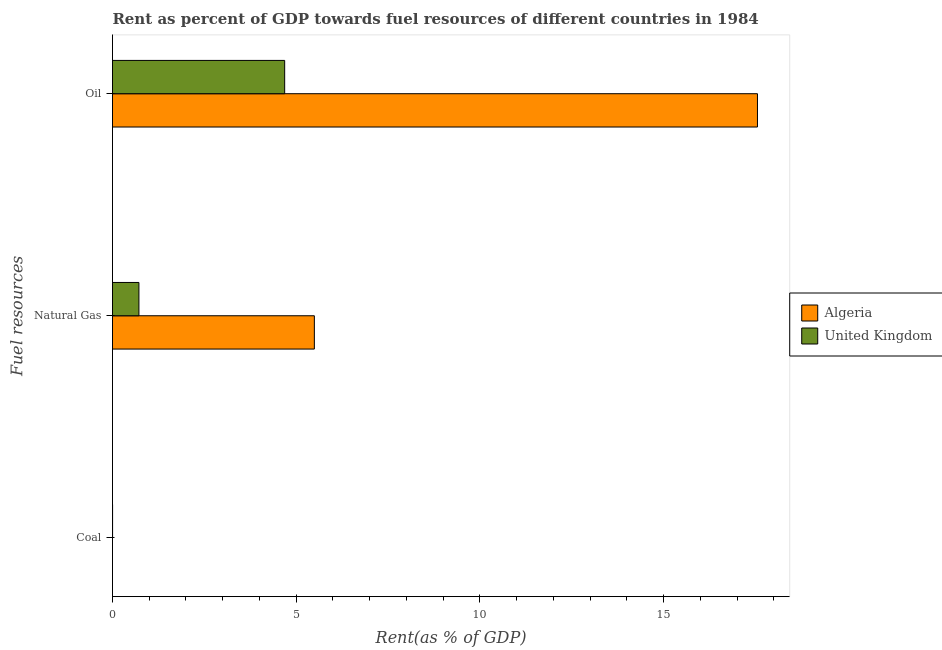How many different coloured bars are there?
Offer a very short reply. 2. How many groups of bars are there?
Make the answer very short. 3. Are the number of bars per tick equal to the number of legend labels?
Offer a terse response. Yes. Are the number of bars on each tick of the Y-axis equal?
Offer a terse response. Yes. What is the label of the 1st group of bars from the top?
Ensure brevity in your answer.  Oil. What is the rent towards oil in Algeria?
Your answer should be compact. 17.56. Across all countries, what is the maximum rent towards oil?
Ensure brevity in your answer.  17.56. Across all countries, what is the minimum rent towards oil?
Ensure brevity in your answer.  4.69. In which country was the rent towards oil minimum?
Your answer should be very brief. United Kingdom. What is the total rent towards natural gas in the graph?
Keep it short and to the point. 6.21. What is the difference between the rent towards natural gas in Algeria and that in United Kingdom?
Provide a short and direct response. 4.78. What is the difference between the rent towards oil in United Kingdom and the rent towards natural gas in Algeria?
Provide a short and direct response. -0.81. What is the average rent towards oil per country?
Provide a succinct answer. 11.12. What is the difference between the rent towards natural gas and rent towards oil in United Kingdom?
Your response must be concise. -3.97. In how many countries, is the rent towards natural gas greater than 7 %?
Ensure brevity in your answer.  0. What is the ratio of the rent towards natural gas in United Kingdom to that in Algeria?
Give a very brief answer. 0.13. Is the difference between the rent towards coal in Algeria and United Kingdom greater than the difference between the rent towards natural gas in Algeria and United Kingdom?
Ensure brevity in your answer.  No. What is the difference between the highest and the second highest rent towards coal?
Give a very brief answer. 0. What is the difference between the highest and the lowest rent towards natural gas?
Your answer should be compact. 4.78. Is the sum of the rent towards natural gas in Algeria and United Kingdom greater than the maximum rent towards coal across all countries?
Provide a short and direct response. Yes. What does the 1st bar from the top in Natural Gas represents?
Your response must be concise. United Kingdom. What does the 2nd bar from the bottom in Coal represents?
Make the answer very short. United Kingdom. Is it the case that in every country, the sum of the rent towards coal and rent towards natural gas is greater than the rent towards oil?
Ensure brevity in your answer.  No. Does the graph contain any zero values?
Keep it short and to the point. No. How many legend labels are there?
Give a very brief answer. 2. How are the legend labels stacked?
Keep it short and to the point. Vertical. What is the title of the graph?
Offer a very short reply. Rent as percent of GDP towards fuel resources of different countries in 1984. What is the label or title of the X-axis?
Your answer should be compact. Rent(as % of GDP). What is the label or title of the Y-axis?
Keep it short and to the point. Fuel resources. What is the Rent(as % of GDP) of Algeria in Coal?
Make the answer very short. 6.52912655872695e-5. What is the Rent(as % of GDP) in United Kingdom in Coal?
Offer a very short reply. 0. What is the Rent(as % of GDP) in Algeria in Natural Gas?
Give a very brief answer. 5.49. What is the Rent(as % of GDP) in United Kingdom in Natural Gas?
Keep it short and to the point. 0.72. What is the Rent(as % of GDP) in Algeria in Oil?
Provide a short and direct response. 17.56. What is the Rent(as % of GDP) of United Kingdom in Oil?
Ensure brevity in your answer.  4.69. Across all Fuel resources, what is the maximum Rent(as % of GDP) in Algeria?
Make the answer very short. 17.56. Across all Fuel resources, what is the maximum Rent(as % of GDP) in United Kingdom?
Your answer should be compact. 4.69. Across all Fuel resources, what is the minimum Rent(as % of GDP) in Algeria?
Provide a succinct answer. 6.52912655872695e-5. Across all Fuel resources, what is the minimum Rent(as % of GDP) in United Kingdom?
Offer a terse response. 0. What is the total Rent(as % of GDP) of Algeria in the graph?
Keep it short and to the point. 23.05. What is the total Rent(as % of GDP) of United Kingdom in the graph?
Your answer should be very brief. 5.41. What is the difference between the Rent(as % of GDP) of Algeria in Coal and that in Natural Gas?
Your answer should be very brief. -5.49. What is the difference between the Rent(as % of GDP) of United Kingdom in Coal and that in Natural Gas?
Keep it short and to the point. -0.72. What is the difference between the Rent(as % of GDP) in Algeria in Coal and that in Oil?
Make the answer very short. -17.56. What is the difference between the Rent(as % of GDP) of United Kingdom in Coal and that in Oil?
Your response must be concise. -4.68. What is the difference between the Rent(as % of GDP) in Algeria in Natural Gas and that in Oil?
Offer a very short reply. -12.06. What is the difference between the Rent(as % of GDP) of United Kingdom in Natural Gas and that in Oil?
Offer a very short reply. -3.97. What is the difference between the Rent(as % of GDP) of Algeria in Coal and the Rent(as % of GDP) of United Kingdom in Natural Gas?
Offer a very short reply. -0.72. What is the difference between the Rent(as % of GDP) in Algeria in Coal and the Rent(as % of GDP) in United Kingdom in Oil?
Ensure brevity in your answer.  -4.69. What is the difference between the Rent(as % of GDP) in Algeria in Natural Gas and the Rent(as % of GDP) in United Kingdom in Oil?
Give a very brief answer. 0.81. What is the average Rent(as % of GDP) in Algeria per Fuel resources?
Ensure brevity in your answer.  7.68. What is the average Rent(as % of GDP) in United Kingdom per Fuel resources?
Your answer should be compact. 1.8. What is the difference between the Rent(as % of GDP) in Algeria and Rent(as % of GDP) in United Kingdom in Coal?
Make the answer very short. -0. What is the difference between the Rent(as % of GDP) in Algeria and Rent(as % of GDP) in United Kingdom in Natural Gas?
Offer a terse response. 4.78. What is the difference between the Rent(as % of GDP) of Algeria and Rent(as % of GDP) of United Kingdom in Oil?
Your response must be concise. 12.87. What is the ratio of the Rent(as % of GDP) of Algeria in Coal to that in Natural Gas?
Your response must be concise. 0. What is the ratio of the Rent(as % of GDP) of United Kingdom in Coal to that in Natural Gas?
Your response must be concise. 0. What is the ratio of the Rent(as % of GDP) in Algeria in Natural Gas to that in Oil?
Your answer should be very brief. 0.31. What is the ratio of the Rent(as % of GDP) of United Kingdom in Natural Gas to that in Oil?
Your answer should be very brief. 0.15. What is the difference between the highest and the second highest Rent(as % of GDP) of Algeria?
Your answer should be very brief. 12.06. What is the difference between the highest and the second highest Rent(as % of GDP) of United Kingdom?
Your answer should be very brief. 3.97. What is the difference between the highest and the lowest Rent(as % of GDP) of Algeria?
Keep it short and to the point. 17.56. What is the difference between the highest and the lowest Rent(as % of GDP) of United Kingdom?
Your answer should be compact. 4.68. 